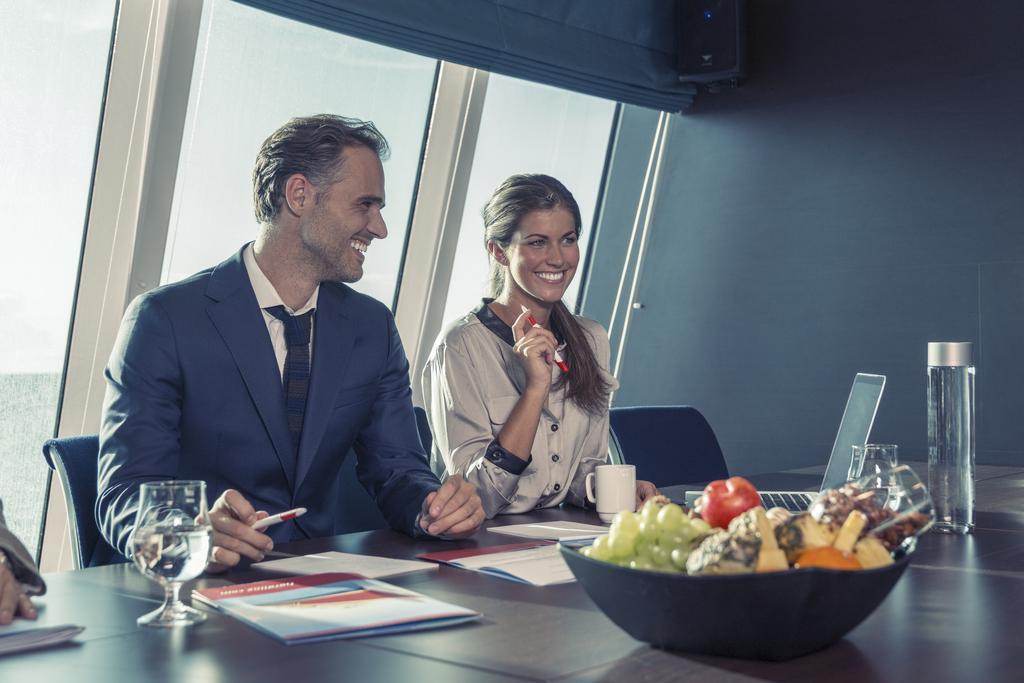Please provide a concise description of this image. In this image I can see a man and a woman are sitting on chairs. I can also see smile on their faces. On this table I can see a bottle, a glass, mug and few papers. 